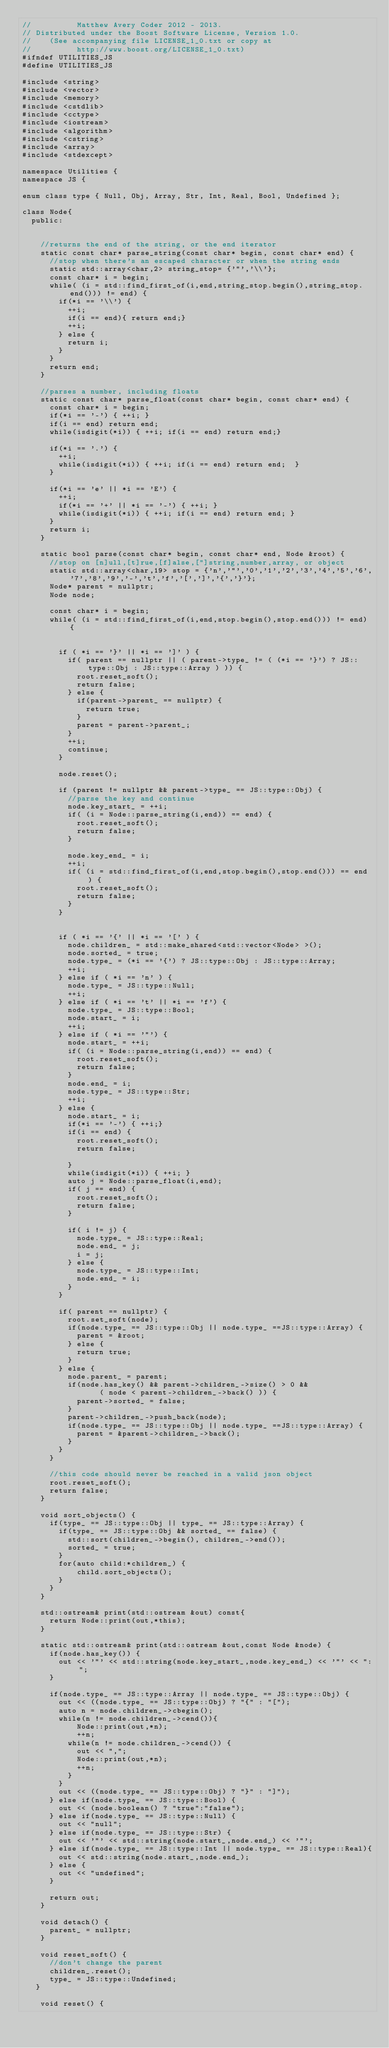<code> <loc_0><loc_0><loc_500><loc_500><_C++_>//          Matthew Avery Coder 2012 - 2013.
// Distributed under the Boost Software License, Version 1.0.
//    (See accompanying file LICENSE_1_0.txt or copy at
//          http://www.boost.org/LICENSE_1_0.txt)
#ifndef UTILITIES_JS
#define UTILITIES_JS

#include <string>
#include <vector>
#include <memory>
#include <cstdlib>
#include <cctype>
#include <iostream>
#include <algorithm>
#include <cstring>
#include <array>
#include <stdexcept>

namespace Utilities {
namespace JS {

enum class type { Null, Obj, Array, Str, Int, Real, Bool, Undefined };

class Node{
  public:


    //returns the end of the string, or the end iterator
    static const char* parse_string(const char* begin, const char* end) {
      //stop when there's an escaped character or when the string ends
      static std::array<char,2> string_stop= {'"','\\'};
      const char* i = begin;
      while( (i = std::find_first_of(i,end,string_stop.begin(),string_stop.end())) != end) {
        if(*i == '\\') {
          ++i;
          if(i == end){ return end;} 
          ++i;
        } else {
          return i;
        }
      }
      return end;
    }
    
    //parses a number, including floats
    static const char* parse_float(const char* begin, const char* end) {
      const char* i = begin;
      if(*i == '-') { ++i; }
      if(i == end) return end;
      while(isdigit(*i)) { ++i; if(i == end) return end;}

      if(*i == '.') { 
        ++i;
        while(isdigit(*i)) { ++i; if(i == end) return end;  }
      }

      if(*i == 'e' || *i == 'E') {
        ++i;
        if(*i == '+' || *i == '-') { ++i; }
        while(isdigit(*i)) { ++i; if(i == end) return end; }
      }
      return i;
    }

    static bool parse(const char* begin, const char* end, Node &root) {
      //stop on [n]ull,[t]rue,[f]alse,["]string,number,array, or object
      static std::array<char,19> stop = {'n','"','0','1','2','3','4','5','6','7','8','9','-','t','f','[',']','{','}'};
      Node* parent = nullptr;
      Node node;

      const char* i = begin;
      while( (i = std::find_first_of(i,end,stop.begin(),stop.end())) != end) {
       

        if ( *i == '}' || *i == ']' ) {
          if( parent == nullptr || ( parent->type_ != ( (*i == '}') ? JS::type::Obj : JS::type::Array ) )) {
            root.reset_soft();
            return false;
          } else {
            if(parent->parent_ == nullptr) {
              return true;
            }
            parent = parent->parent_;
          }
          ++i;
          continue;
        }

        node.reset();
        
        if (parent != nullptr && parent->type_ == JS::type::Obj) {
          //parse the key and continue
          node.key_start_ = ++i;
          if( (i = Node::parse_string(i,end)) == end) {
            root.reset_soft();
            return false;
          }

          node.key_end_ = i;
          ++i;
          if( (i = std::find_first_of(i,end,stop.begin(),stop.end())) == end ) {
            root.reset_soft();
            return false;
          }
        }


        if ( *i == '{' || *i == '[' ) {
          node.children_ = std::make_shared<std::vector<Node> >();
          node.sorted_ = true;
          node.type_ = (*i == '{') ? JS::type::Obj : JS::type::Array;
          ++i;
        } else if ( *i == 'n' ) {
          node.type_ = JS::type::Null;
          ++i;
        } else if ( *i == 't' || *i == 'f') {
          node.type_ = JS::type::Bool;
          node.start_ = i;
          ++i;
        } else if ( *i == '"') {
          node.start_ = ++i;
          if( (i = Node::parse_string(i,end)) == end) {
            root.reset_soft();
            return false;
          }
          node.end_ = i;
          node.type_ = JS::type::Str;
          ++i;
        } else {
          node.start_ = i;
          if(*i == '-') { ++i;}
          if(i == end) {
            root.reset_soft();
            return false;

          }
          while(isdigit(*i)) { ++i; }
          auto j = Node::parse_float(i,end);
          if( j == end) {
            root.reset_soft();
            return false;
          } 

          if( i != j) {
            node.type_ = JS::type::Real;
            node.end_ = j;
            i = j;
          } else {
            node.type_ = JS::type::Int;
            node.end_ = i;
          }
        }
        
        if( parent == nullptr) {
          root.set_soft(node);
          if(node.type_ == JS::type::Obj || node.type_ ==JS::type::Array) {
            parent = &root;
          } else {
            return true;
          }
        } else {
          node.parent_ = parent; 
          if(node.has_key() && parent->children_->size() > 0 &&
                 ( node < parent->children_->back() )) {
            parent->sorted_ = false;
          }
          parent->children_->push_back(node);
          if(node.type_ == JS::type::Obj || node.type_ ==JS::type::Array) {
            parent = &parent->children_->back();
          }
        }
      }

      //this code should never be reached in a valid json object
      root.reset_soft();
      return false;
    }

    void sort_objects() {
      if(type_ == JS::type::Obj || type_ == JS::type::Array) {
        if(type_ == JS::type::Obj && sorted_ == false) {
          std::sort(children_->begin(), children_->end());
          sorted_ = true;
        }
        for(auto child:*children_) {
            child.sort_objects();
        }
      }
    }

    std::ostream& print(std::ostream &out) const{
      return Node::print(out,*this);
    }
  
    static std::ostream& print(std::ostream &out,const Node &node) {
      if(node.has_key()) {
        out << '"' << std::string(node.key_start_,node.key_end_) << '"' << ":";
      }

      if(node.type_ == JS::type::Array || node.type_ == JS::type::Obj) {
        out << ((node.type_ == JS::type::Obj) ? "{" : "[");
        auto n = node.children_->cbegin();
        while(n != node.children_->cend()){
            Node::print(out,*n);
            ++n;
          while(n != node.children_->cend()) {
            out << ",";
            Node::print(out,*n);
            ++n;
          }
        }
        out << ((node.type_ == JS::type::Obj) ? "}" : "]");
      } else if(node.type_ == JS::type::Bool) {
        out << (node.boolean() ? "true":"false");
      } else if(node.type_ == JS::type::Null) {
        out << "null";
      } else if(node.type_ == JS::type::Str) {
        out << '"' << std::string(node.start_,node.end_) << '"';
      } else if(node.type_ == JS::type::Int || node.type_ == JS::type::Real){
        out << std::string(node.start_,node.end_);
      } else {
        out << "undefined";
      }

      return out;
    }

    void detach() {
      parent_ = nullptr;
    }

    void reset_soft() {
      //don't change the parent
      children_.reset();
      type_ = JS::type::Undefined;
   }

    void reset() {</code> 